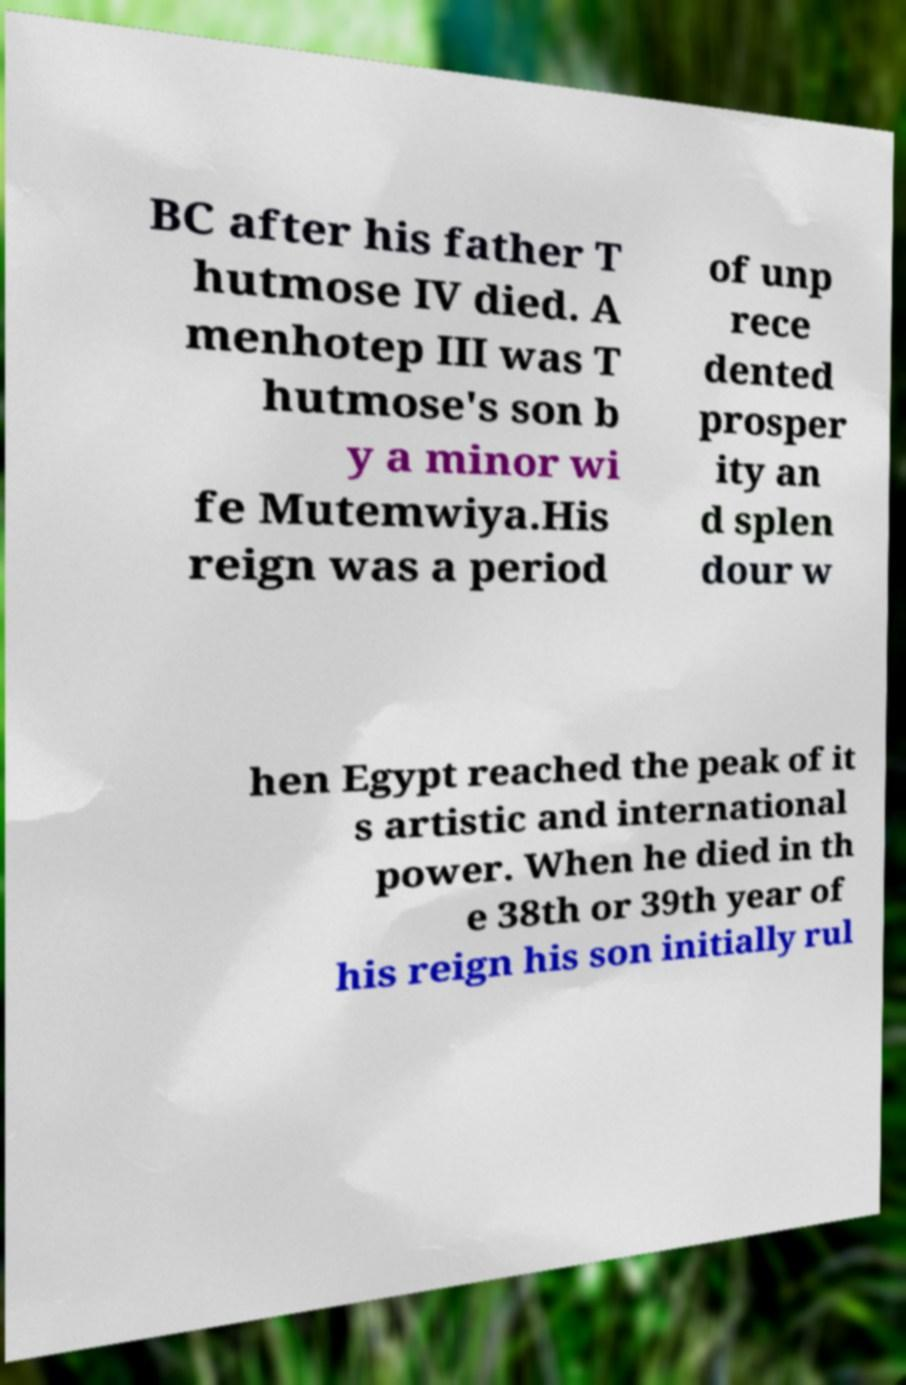For documentation purposes, I need the text within this image transcribed. Could you provide that? BC after his father T hutmose IV died. A menhotep III was T hutmose's son b y a minor wi fe Mutemwiya.His reign was a period of unp rece dented prosper ity an d splen dour w hen Egypt reached the peak of it s artistic and international power. When he died in th e 38th or 39th year of his reign his son initially rul 